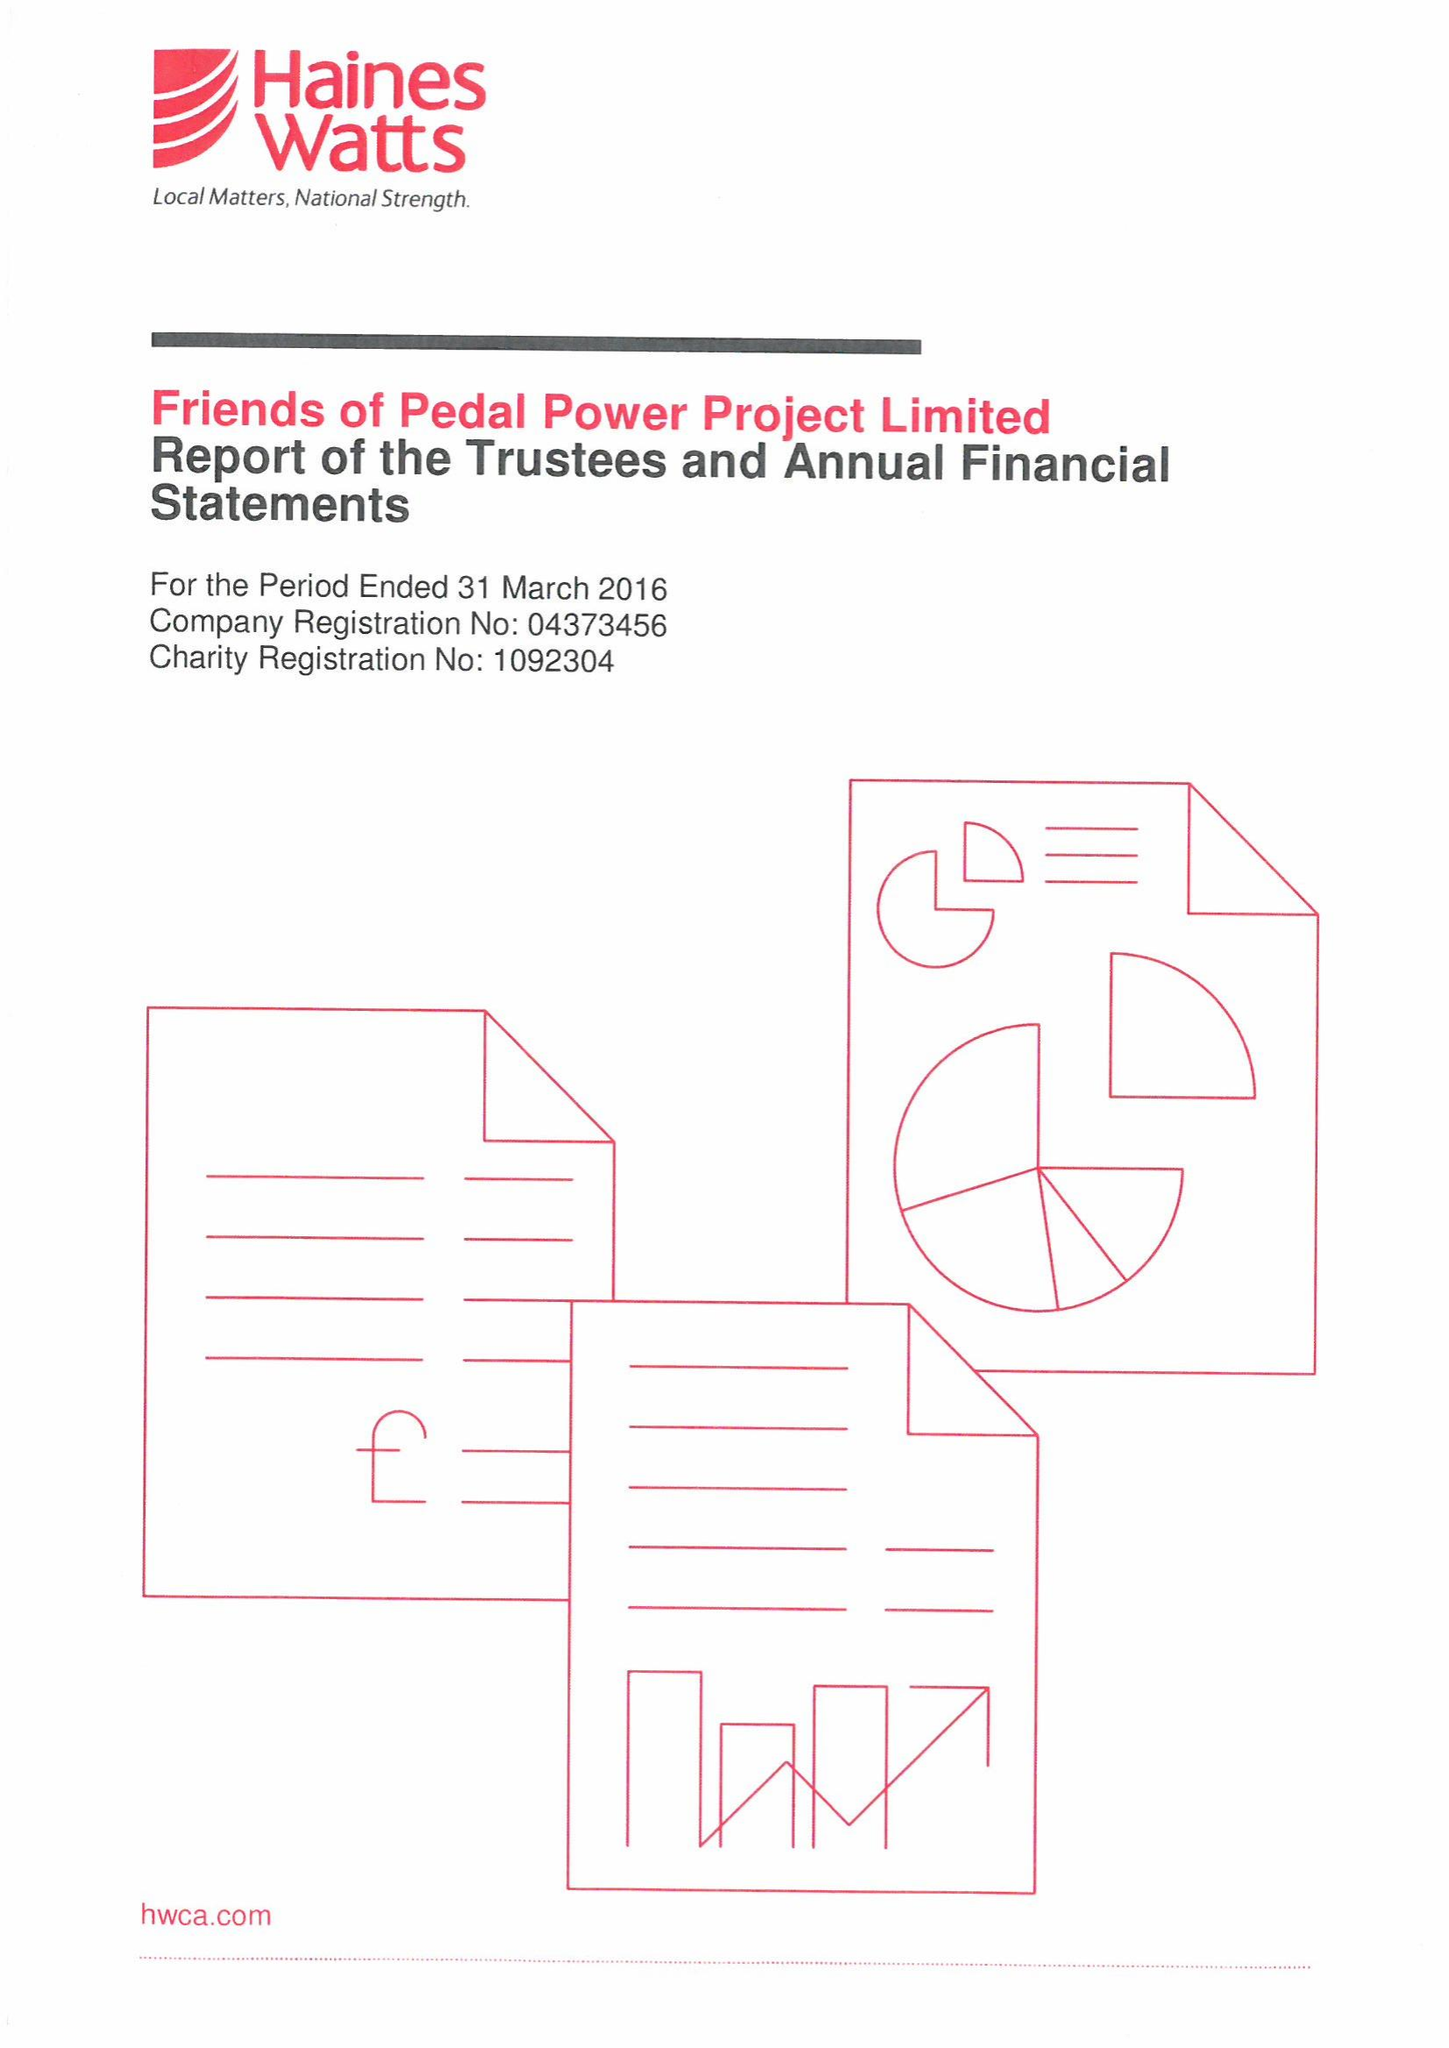What is the value for the spending_annually_in_british_pounds?
Answer the question using a single word or phrase. 385387.00 